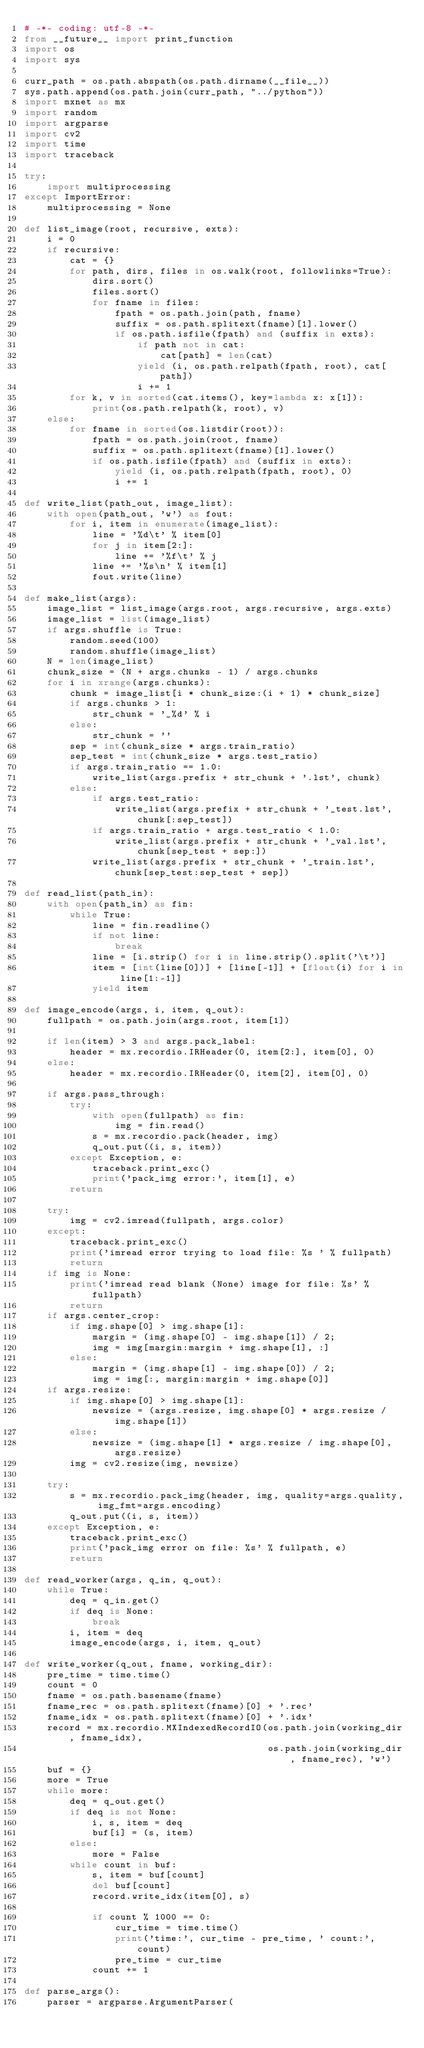<code> <loc_0><loc_0><loc_500><loc_500><_Python_># -*- coding: utf-8 -*-
from __future__ import print_function
import os
import sys

curr_path = os.path.abspath(os.path.dirname(__file__))
sys.path.append(os.path.join(curr_path, "../python"))
import mxnet as mx
import random
import argparse
import cv2
import time
import traceback

try:
    import multiprocessing
except ImportError:
    multiprocessing = None

def list_image(root, recursive, exts):
    i = 0
    if recursive:
        cat = {}
        for path, dirs, files in os.walk(root, followlinks=True):
            dirs.sort()
            files.sort()
            for fname in files:
                fpath = os.path.join(path, fname)
                suffix = os.path.splitext(fname)[1].lower()
                if os.path.isfile(fpath) and (suffix in exts):
                    if path not in cat:
                        cat[path] = len(cat)
                    yield (i, os.path.relpath(fpath, root), cat[path])
                    i += 1
        for k, v in sorted(cat.items(), key=lambda x: x[1]):
            print(os.path.relpath(k, root), v)
    else:
        for fname in sorted(os.listdir(root)):
            fpath = os.path.join(root, fname)
            suffix = os.path.splitext(fname)[1].lower()
            if os.path.isfile(fpath) and (suffix in exts):
                yield (i, os.path.relpath(fpath, root), 0)
                i += 1

def write_list(path_out, image_list):
    with open(path_out, 'w') as fout:
        for i, item in enumerate(image_list):
            line = '%d\t' % item[0]
            for j in item[2:]:
                line += '%f\t' % j
            line += '%s\n' % item[1]
            fout.write(line)

def make_list(args):
    image_list = list_image(args.root, args.recursive, args.exts)
    image_list = list(image_list)
    if args.shuffle is True:
        random.seed(100)
        random.shuffle(image_list)
    N = len(image_list)
    chunk_size = (N + args.chunks - 1) / args.chunks
    for i in xrange(args.chunks):
        chunk = image_list[i * chunk_size:(i + 1) * chunk_size]
        if args.chunks > 1:
            str_chunk = '_%d' % i
        else:
            str_chunk = ''
        sep = int(chunk_size * args.train_ratio)
        sep_test = int(chunk_size * args.test_ratio)
        if args.train_ratio == 1.0:
            write_list(args.prefix + str_chunk + '.lst', chunk)
        else:
            if args.test_ratio:
                write_list(args.prefix + str_chunk + '_test.lst', chunk[:sep_test])
            if args.train_ratio + args.test_ratio < 1.0:
                write_list(args.prefix + str_chunk + '_val.lst', chunk[sep_test + sep:])
            write_list(args.prefix + str_chunk + '_train.lst', chunk[sep_test:sep_test + sep])

def read_list(path_in):
    with open(path_in) as fin:
        while True:
            line = fin.readline()
            if not line:
                break
            line = [i.strip() for i in line.strip().split('\t')]
            item = [int(line[0])] + [line[-1]] + [float(i) for i in line[1:-1]]
            yield item

def image_encode(args, i, item, q_out):
    fullpath = os.path.join(args.root, item[1])

    if len(item) > 3 and args.pack_label:
        header = mx.recordio.IRHeader(0, item[2:], item[0], 0)
    else:
        header = mx.recordio.IRHeader(0, item[2], item[0], 0)

    if args.pass_through:
        try:
            with open(fullpath) as fin:
                img = fin.read()
            s = mx.recordio.pack(header, img)
            q_out.put((i, s, item))
        except Exception, e:
            traceback.print_exc()
            print('pack_img error:', item[1], e)
        return

    try:
        img = cv2.imread(fullpath, args.color)
    except:
        traceback.print_exc()
        print('imread error trying to load file: %s ' % fullpath)
        return
    if img is None:
        print('imread read blank (None) image for file: %s' % fullpath)
        return
    if args.center_crop:
        if img.shape[0] > img.shape[1]:
            margin = (img.shape[0] - img.shape[1]) / 2;
            img = img[margin:margin + img.shape[1], :]
        else:
            margin = (img.shape[1] - img.shape[0]) / 2;
            img = img[:, margin:margin + img.shape[0]]
    if args.resize:
        if img.shape[0] > img.shape[1]:
            newsize = (args.resize, img.shape[0] * args.resize / img.shape[1])
        else:
            newsize = (img.shape[1] * args.resize / img.shape[0], args.resize)
        img = cv2.resize(img, newsize)

    try:
        s = mx.recordio.pack_img(header, img, quality=args.quality, img_fmt=args.encoding)
        q_out.put((i, s, item))
    except Exception, e:
        traceback.print_exc()
        print('pack_img error on file: %s' % fullpath, e)
        return

def read_worker(args, q_in, q_out):
    while True:
        deq = q_in.get()
        if deq is None:
            break
        i, item = deq
        image_encode(args, i, item, q_out)

def write_worker(q_out, fname, working_dir):
    pre_time = time.time()
    count = 0
    fname = os.path.basename(fname)
    fname_rec = os.path.splitext(fname)[0] + '.rec'
    fname_idx = os.path.splitext(fname)[0] + '.idx'
    record = mx.recordio.MXIndexedRecordIO(os.path.join(working_dir, fname_idx),
                                           os.path.join(working_dir, fname_rec), 'w')
    buf = {}
    more = True
    while more:
        deq = q_out.get()
        if deq is not None:
            i, s, item = deq
            buf[i] = (s, item)
        else:
            more = False
        while count in buf:
            s, item = buf[count]
            del buf[count]
            record.write_idx(item[0], s)

            if count % 1000 == 0:
                cur_time = time.time()
                print('time:', cur_time - pre_time, ' count:', count)
                pre_time = cur_time
            count += 1

def parse_args():
    parser = argparse.ArgumentParser(</code> 